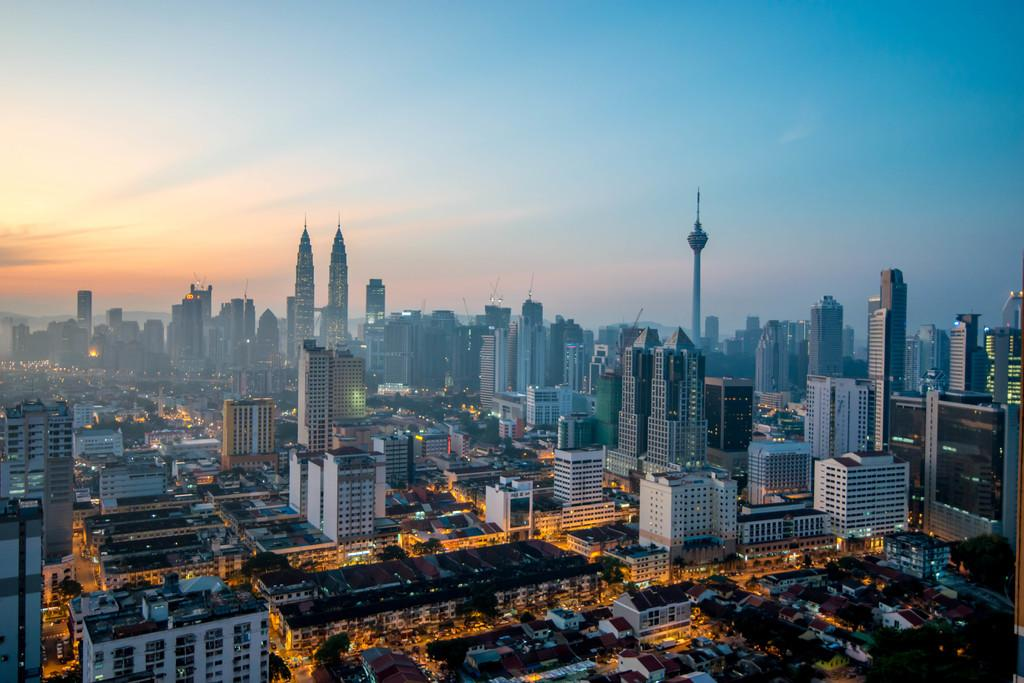What type of view is shown in the image? The image is an aerial view. What structures can be seen in the image? There are buildings and a tower in the image. Are there any illuminated objects in the image? Yes, there are lights in the image. What architectural features can be observed in the buildings? There are windows in the image. What type of natural element is present in the image? There are trees in the image. What is visible at the top of the image? The sky is visible at the top of the image. What type of plastic material is covering the trees in the image? There is no plastic material covering the trees in the image; the trees are visible in their natural state. 